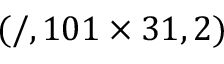Convert formula to latex. <formula><loc_0><loc_0><loc_500><loc_500>( / , 1 0 1 \times 3 1 , 2 )</formula> 